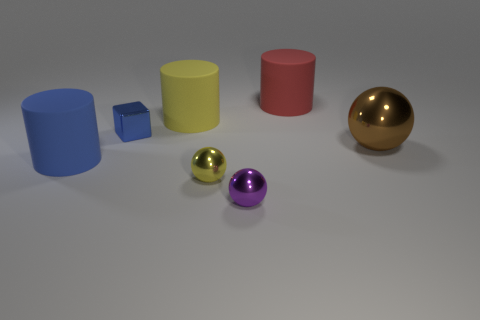Add 3 red metallic cylinders. How many objects exist? 10 Subtract all cubes. How many objects are left? 6 Subtract all cyan cylinders. Subtract all big cylinders. How many objects are left? 4 Add 1 cubes. How many cubes are left? 2 Add 5 tiny gray shiny cylinders. How many tiny gray shiny cylinders exist? 5 Subtract 0 brown cubes. How many objects are left? 7 